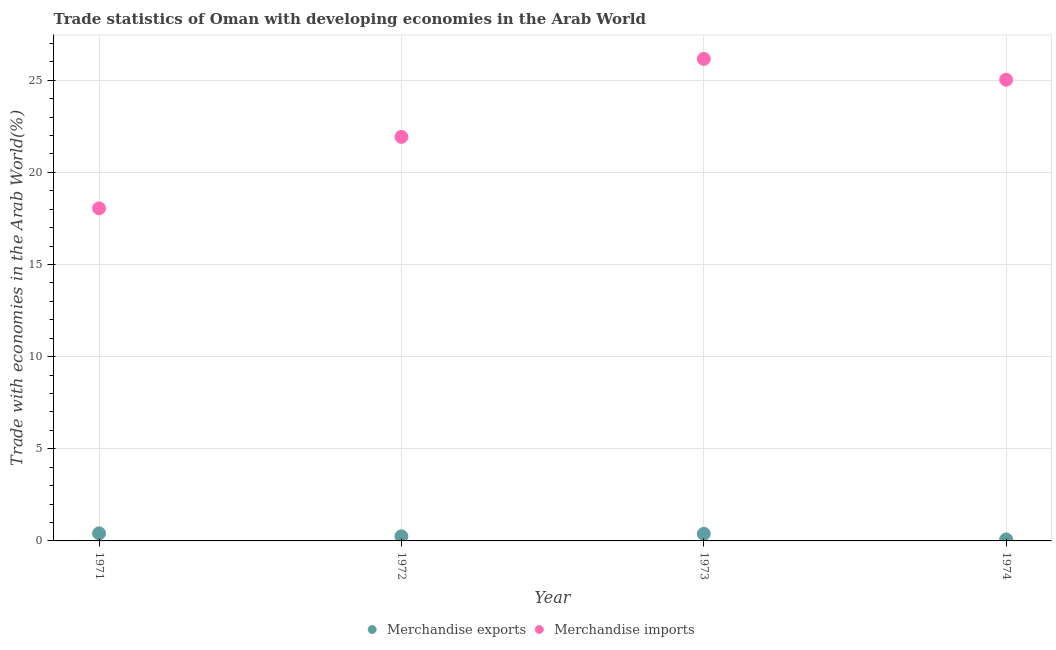Is the number of dotlines equal to the number of legend labels?
Your answer should be very brief. Yes. What is the merchandise exports in 1971?
Your answer should be very brief. 0.41. Across all years, what is the maximum merchandise exports?
Your answer should be compact. 0.41. Across all years, what is the minimum merchandise exports?
Your answer should be compact. 0.08. What is the total merchandise imports in the graph?
Offer a very short reply. 91.16. What is the difference between the merchandise imports in 1971 and that in 1973?
Your answer should be compact. -8.11. What is the difference between the merchandise exports in 1972 and the merchandise imports in 1974?
Your answer should be very brief. -24.78. What is the average merchandise exports per year?
Ensure brevity in your answer.  0.28. In the year 1972, what is the difference between the merchandise imports and merchandise exports?
Provide a short and direct response. 21.68. In how many years, is the merchandise imports greater than 3 %?
Your answer should be compact. 4. What is the ratio of the merchandise imports in 1971 to that in 1974?
Your answer should be very brief. 0.72. What is the difference between the highest and the second highest merchandise imports?
Your answer should be compact. 1.13. What is the difference between the highest and the lowest merchandise exports?
Your answer should be compact. 0.33. Is the sum of the merchandise exports in 1971 and 1974 greater than the maximum merchandise imports across all years?
Provide a short and direct response. No. Does the merchandise exports monotonically increase over the years?
Keep it short and to the point. No. Is the merchandise exports strictly greater than the merchandise imports over the years?
Provide a succinct answer. No. What is the difference between two consecutive major ticks on the Y-axis?
Your response must be concise. 5. Does the graph contain grids?
Provide a short and direct response. Yes. Where does the legend appear in the graph?
Give a very brief answer. Bottom center. How many legend labels are there?
Offer a terse response. 2. What is the title of the graph?
Provide a succinct answer. Trade statistics of Oman with developing economies in the Arab World. Does "current US$" appear as one of the legend labels in the graph?
Provide a succinct answer. No. What is the label or title of the Y-axis?
Make the answer very short. Trade with economies in the Arab World(%). What is the Trade with economies in the Arab World(%) of Merchandise exports in 1971?
Provide a short and direct response. 0.41. What is the Trade with economies in the Arab World(%) in Merchandise imports in 1971?
Offer a very short reply. 18.05. What is the Trade with economies in the Arab World(%) of Merchandise exports in 1972?
Offer a terse response. 0.25. What is the Trade with economies in the Arab World(%) in Merchandise imports in 1972?
Give a very brief answer. 21.93. What is the Trade with economies in the Arab World(%) of Merchandise exports in 1973?
Your response must be concise. 0.38. What is the Trade with economies in the Arab World(%) of Merchandise imports in 1973?
Provide a short and direct response. 26.16. What is the Trade with economies in the Arab World(%) of Merchandise exports in 1974?
Your answer should be very brief. 0.08. What is the Trade with economies in the Arab World(%) in Merchandise imports in 1974?
Provide a succinct answer. 25.03. Across all years, what is the maximum Trade with economies in the Arab World(%) in Merchandise exports?
Offer a terse response. 0.41. Across all years, what is the maximum Trade with economies in the Arab World(%) of Merchandise imports?
Your answer should be very brief. 26.16. Across all years, what is the minimum Trade with economies in the Arab World(%) in Merchandise exports?
Your answer should be very brief. 0.08. Across all years, what is the minimum Trade with economies in the Arab World(%) in Merchandise imports?
Your answer should be very brief. 18.05. What is the total Trade with economies in the Arab World(%) of Merchandise exports in the graph?
Provide a succinct answer. 1.13. What is the total Trade with economies in the Arab World(%) of Merchandise imports in the graph?
Offer a very short reply. 91.17. What is the difference between the Trade with economies in the Arab World(%) of Merchandise exports in 1971 and that in 1972?
Offer a terse response. 0.16. What is the difference between the Trade with economies in the Arab World(%) of Merchandise imports in 1971 and that in 1972?
Your answer should be very brief. -3.88. What is the difference between the Trade with economies in the Arab World(%) in Merchandise exports in 1971 and that in 1973?
Keep it short and to the point. 0.03. What is the difference between the Trade with economies in the Arab World(%) of Merchandise imports in 1971 and that in 1973?
Your answer should be compact. -8.11. What is the difference between the Trade with economies in the Arab World(%) of Merchandise exports in 1971 and that in 1974?
Ensure brevity in your answer.  0.33. What is the difference between the Trade with economies in the Arab World(%) in Merchandise imports in 1971 and that in 1974?
Your answer should be compact. -6.98. What is the difference between the Trade with economies in the Arab World(%) of Merchandise exports in 1972 and that in 1973?
Keep it short and to the point. -0.13. What is the difference between the Trade with economies in the Arab World(%) in Merchandise imports in 1972 and that in 1973?
Offer a terse response. -4.23. What is the difference between the Trade with economies in the Arab World(%) of Merchandise exports in 1972 and that in 1974?
Give a very brief answer. 0.17. What is the difference between the Trade with economies in the Arab World(%) in Merchandise imports in 1972 and that in 1974?
Your response must be concise. -3.1. What is the difference between the Trade with economies in the Arab World(%) in Merchandise exports in 1973 and that in 1974?
Your answer should be compact. 0.3. What is the difference between the Trade with economies in the Arab World(%) in Merchandise imports in 1973 and that in 1974?
Your answer should be very brief. 1.13. What is the difference between the Trade with economies in the Arab World(%) in Merchandise exports in 1971 and the Trade with economies in the Arab World(%) in Merchandise imports in 1972?
Ensure brevity in your answer.  -21.52. What is the difference between the Trade with economies in the Arab World(%) of Merchandise exports in 1971 and the Trade with economies in the Arab World(%) of Merchandise imports in 1973?
Provide a succinct answer. -25.75. What is the difference between the Trade with economies in the Arab World(%) in Merchandise exports in 1971 and the Trade with economies in the Arab World(%) in Merchandise imports in 1974?
Give a very brief answer. -24.62. What is the difference between the Trade with economies in the Arab World(%) of Merchandise exports in 1972 and the Trade with economies in the Arab World(%) of Merchandise imports in 1973?
Your answer should be compact. -25.91. What is the difference between the Trade with economies in the Arab World(%) in Merchandise exports in 1972 and the Trade with economies in the Arab World(%) in Merchandise imports in 1974?
Provide a succinct answer. -24.78. What is the difference between the Trade with economies in the Arab World(%) of Merchandise exports in 1973 and the Trade with economies in the Arab World(%) of Merchandise imports in 1974?
Offer a terse response. -24.64. What is the average Trade with economies in the Arab World(%) in Merchandise exports per year?
Your answer should be very brief. 0.28. What is the average Trade with economies in the Arab World(%) of Merchandise imports per year?
Give a very brief answer. 22.79. In the year 1971, what is the difference between the Trade with economies in the Arab World(%) of Merchandise exports and Trade with economies in the Arab World(%) of Merchandise imports?
Offer a terse response. -17.64. In the year 1972, what is the difference between the Trade with economies in the Arab World(%) of Merchandise exports and Trade with economies in the Arab World(%) of Merchandise imports?
Ensure brevity in your answer.  -21.68. In the year 1973, what is the difference between the Trade with economies in the Arab World(%) of Merchandise exports and Trade with economies in the Arab World(%) of Merchandise imports?
Provide a short and direct response. -25.77. In the year 1974, what is the difference between the Trade with economies in the Arab World(%) of Merchandise exports and Trade with economies in the Arab World(%) of Merchandise imports?
Ensure brevity in your answer.  -24.95. What is the ratio of the Trade with economies in the Arab World(%) in Merchandise exports in 1971 to that in 1972?
Give a very brief answer. 1.64. What is the ratio of the Trade with economies in the Arab World(%) in Merchandise imports in 1971 to that in 1972?
Keep it short and to the point. 0.82. What is the ratio of the Trade with economies in the Arab World(%) in Merchandise exports in 1971 to that in 1973?
Ensure brevity in your answer.  1.07. What is the ratio of the Trade with economies in the Arab World(%) in Merchandise imports in 1971 to that in 1973?
Keep it short and to the point. 0.69. What is the ratio of the Trade with economies in the Arab World(%) of Merchandise exports in 1971 to that in 1974?
Give a very brief answer. 5.09. What is the ratio of the Trade with economies in the Arab World(%) of Merchandise imports in 1971 to that in 1974?
Keep it short and to the point. 0.72. What is the ratio of the Trade with economies in the Arab World(%) of Merchandise exports in 1972 to that in 1973?
Offer a very short reply. 0.65. What is the ratio of the Trade with economies in the Arab World(%) in Merchandise imports in 1972 to that in 1973?
Ensure brevity in your answer.  0.84. What is the ratio of the Trade with economies in the Arab World(%) of Merchandise exports in 1972 to that in 1974?
Provide a succinct answer. 3.1. What is the ratio of the Trade with economies in the Arab World(%) of Merchandise imports in 1972 to that in 1974?
Offer a very short reply. 0.88. What is the ratio of the Trade with economies in the Arab World(%) of Merchandise exports in 1973 to that in 1974?
Your response must be concise. 4.76. What is the ratio of the Trade with economies in the Arab World(%) in Merchandise imports in 1973 to that in 1974?
Offer a terse response. 1.05. What is the difference between the highest and the second highest Trade with economies in the Arab World(%) in Merchandise exports?
Offer a very short reply. 0.03. What is the difference between the highest and the second highest Trade with economies in the Arab World(%) in Merchandise imports?
Your answer should be compact. 1.13. What is the difference between the highest and the lowest Trade with economies in the Arab World(%) of Merchandise exports?
Keep it short and to the point. 0.33. What is the difference between the highest and the lowest Trade with economies in the Arab World(%) of Merchandise imports?
Provide a succinct answer. 8.11. 